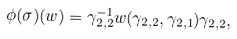Convert formula to latex. <formula><loc_0><loc_0><loc_500><loc_500>\phi ( \sigma ) ( w ) = \gamma _ { 2 , 2 } ^ { - 1 } w ( \gamma _ { 2 , 2 } , \gamma _ { 2 , 1 } ) \gamma _ { 2 , 2 } ,</formula> 